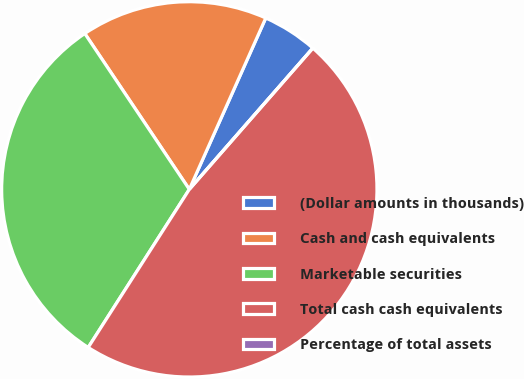Convert chart. <chart><loc_0><loc_0><loc_500><loc_500><pie_chart><fcel>(Dollar amounts in thousands)<fcel>Cash and cash equivalents<fcel>Marketable securities<fcel>Total cash cash equivalents<fcel>Percentage of total assets<nl><fcel>4.76%<fcel>16.08%<fcel>31.54%<fcel>47.62%<fcel>0.0%<nl></chart> 